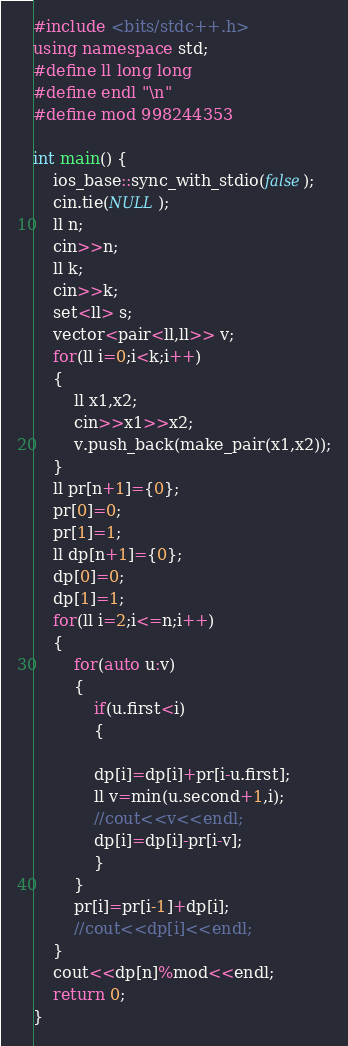<code> <loc_0><loc_0><loc_500><loc_500><_C++_>#include <bits/stdc++.h>
using namespace std;
#define ll long long
#define endl "\n"
#define mod 998244353

int main() {
	ios_base::sync_with_stdio(false);
    cin.tie(NULL);
    ll n;
    cin>>n;
    ll k;
    cin>>k;
    set<ll> s;
    vector<pair<ll,ll>> v;
    for(ll i=0;i<k;i++)
    {
    	ll x1,x2;
    	cin>>x1>>x2;
    	v.push_back(make_pair(x1,x2));
    }
    ll pr[n+1]={0};
    pr[0]=0;
    pr[1]=1;
    ll dp[n+1]={0};
    dp[0]=0;
    dp[1]=1;
    for(ll i=2;i<=n;i++)
    {
    	for(auto u:v)
    	{
    		if(u.first<i)
    		{
    		
    	    dp[i]=dp[i]+pr[i-u.first];
    		ll v=min(u.second+1,i);
    		//cout<<v<<endl;
    		dp[i]=dp[i]-pr[i-v];
    		}
    	}
    	pr[i]=pr[i-1]+dp[i];
    	//cout<<dp[i]<<endl;
    }
    cout<<dp[n]%mod<<endl;
	return 0;
}</code> 